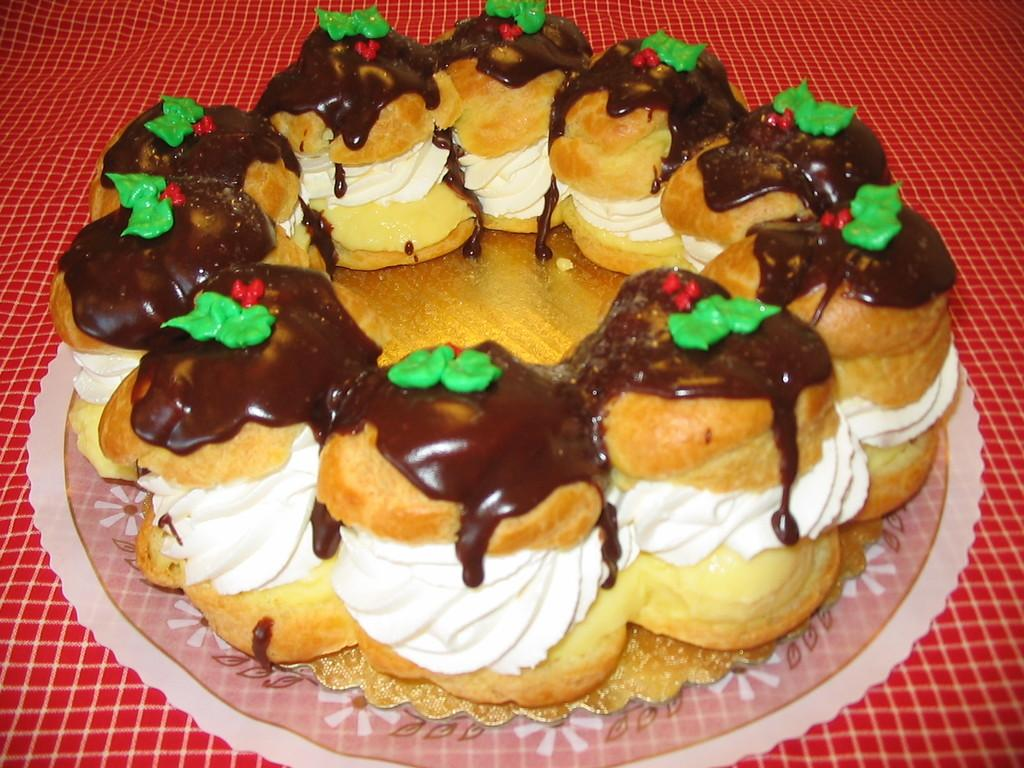What is on the plate in the image? There are cupcakes on the plate in the image. What can be seen on the cupcakes? There is creme visible on the cupcakes. What is located at the bottom of the image? There is a cloth at the bottom of the image. What type of tree is growing in the jail cell in the image? There is no tree or jail cell present in the image; it features a plate with cupcakes and a cloth at the bottom. 